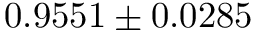Convert formula to latex. <formula><loc_0><loc_0><loc_500><loc_500>0 . 9 5 5 1 \pm 0 . 0 2 8 5</formula> 